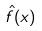Convert formula to latex. <formula><loc_0><loc_0><loc_500><loc_500>\hat { f } ( x )</formula> 